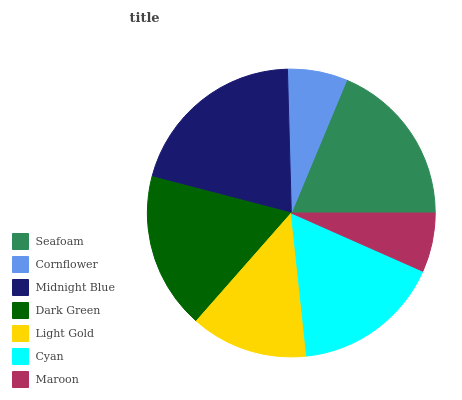Is Maroon the minimum?
Answer yes or no. Yes. Is Midnight Blue the maximum?
Answer yes or no. Yes. Is Cornflower the minimum?
Answer yes or no. No. Is Cornflower the maximum?
Answer yes or no. No. Is Seafoam greater than Cornflower?
Answer yes or no. Yes. Is Cornflower less than Seafoam?
Answer yes or no. Yes. Is Cornflower greater than Seafoam?
Answer yes or no. No. Is Seafoam less than Cornflower?
Answer yes or no. No. Is Cyan the high median?
Answer yes or no. Yes. Is Cyan the low median?
Answer yes or no. Yes. Is Seafoam the high median?
Answer yes or no. No. Is Seafoam the low median?
Answer yes or no. No. 